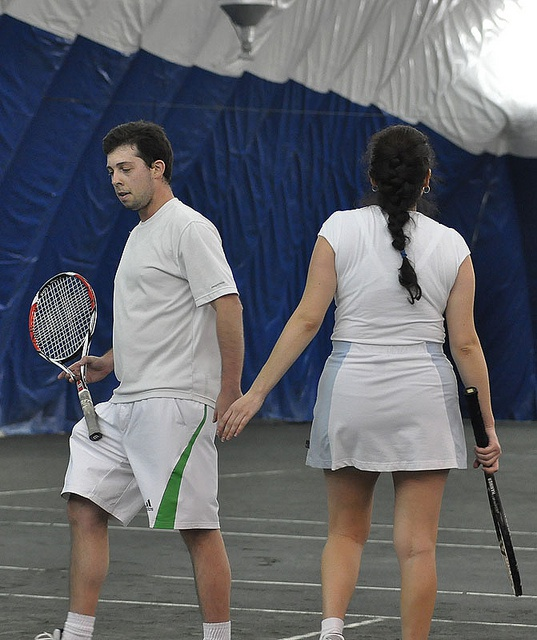Describe the objects in this image and their specific colors. I can see people in gray, darkgray, lightgray, and black tones, people in gray, darkgray, and lightgray tones, tennis racket in gray, black, darkgray, and lightgray tones, and tennis racket in gray, black, and darkgray tones in this image. 